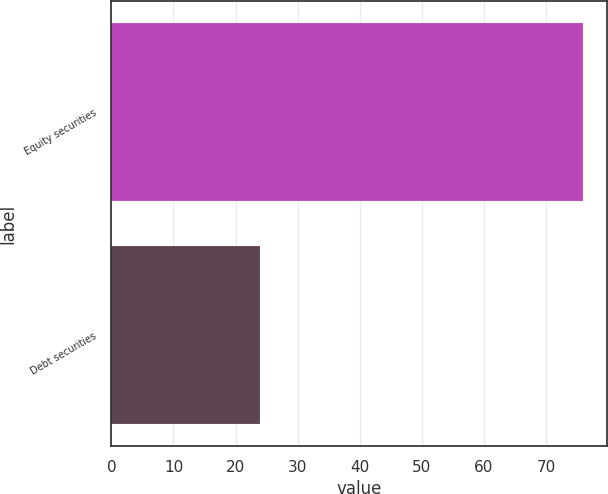Convert chart to OTSL. <chart><loc_0><loc_0><loc_500><loc_500><bar_chart><fcel>Equity securities<fcel>Debt securities<nl><fcel>76<fcel>24<nl></chart> 